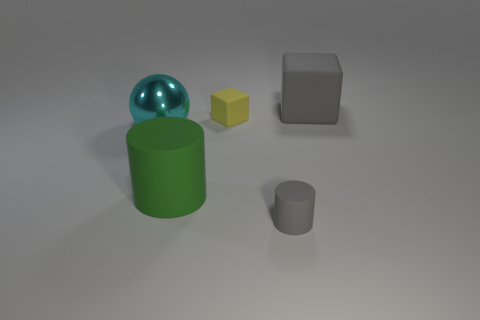Add 2 large shiny things. How many objects exist? 7 Subtract all blocks. How many objects are left? 3 Subtract 0 blue spheres. How many objects are left? 5 Subtract all tiny brown rubber spheres. Subtract all small matte cubes. How many objects are left? 4 Add 1 tiny objects. How many tiny objects are left? 3 Add 4 yellow matte things. How many yellow matte things exist? 5 